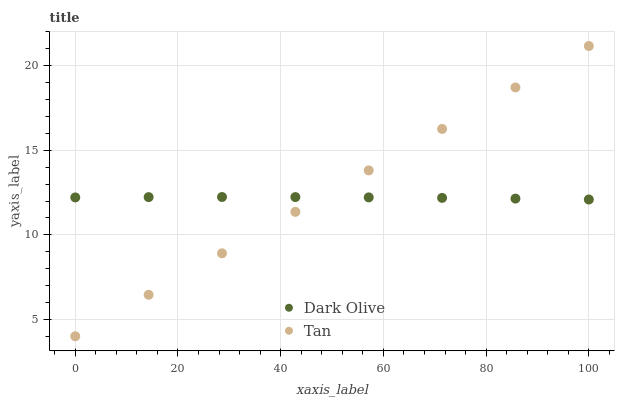Does Dark Olive have the minimum area under the curve?
Answer yes or no. Yes. Does Tan have the maximum area under the curve?
Answer yes or no. Yes. Does Dark Olive have the maximum area under the curve?
Answer yes or no. No. Is Tan the smoothest?
Answer yes or no. Yes. Is Dark Olive the roughest?
Answer yes or no. Yes. Is Dark Olive the smoothest?
Answer yes or no. No. Does Tan have the lowest value?
Answer yes or no. Yes. Does Dark Olive have the lowest value?
Answer yes or no. No. Does Tan have the highest value?
Answer yes or no. Yes. Does Dark Olive have the highest value?
Answer yes or no. No. Does Dark Olive intersect Tan?
Answer yes or no. Yes. Is Dark Olive less than Tan?
Answer yes or no. No. Is Dark Olive greater than Tan?
Answer yes or no. No. 